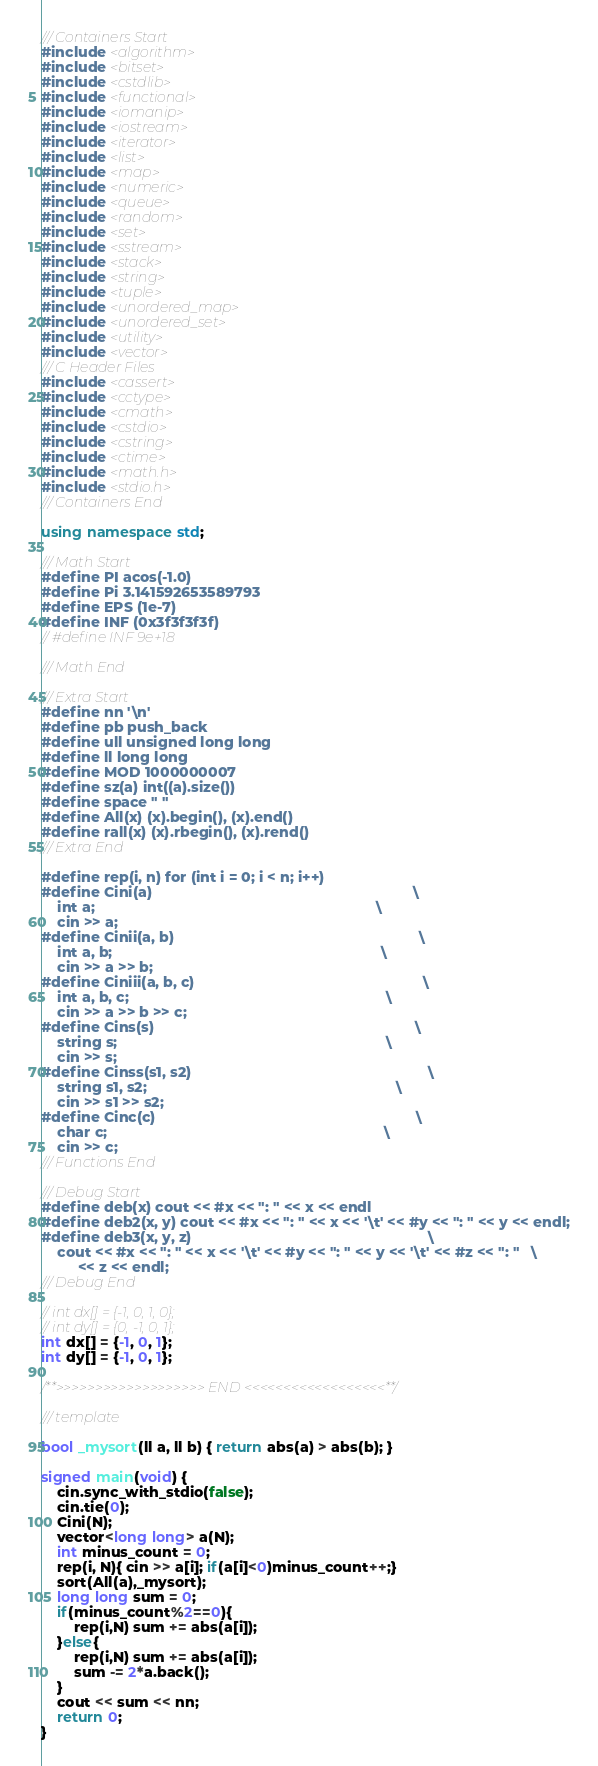Convert code to text. <code><loc_0><loc_0><loc_500><loc_500><_C++_>/// Containers Start
#include <algorithm>
#include <bitset>
#include <cstdlib>
#include <functional>
#include <iomanip>
#include <iostream>
#include <iterator>
#include <list>
#include <map>
#include <numeric>
#include <queue>
#include <random>
#include <set>
#include <sstream>
#include <stack>
#include <string>
#include <tuple>
#include <unordered_map>
#include <unordered_set>
#include <utility>
#include <vector>
/// C Header Files
#include <cassert>
#include <cctype>
#include <cmath>
#include <cstdio>
#include <cstring>
#include <ctime>
#include <math.h>
#include <stdio.h>
/// Containers End

using namespace std;

/// Math Start
#define PI acos(-1.0)
#define Pi 3.141592653589793
#define EPS (1e-7)
#define INF (0x3f3f3f3f)
// #define INF 9e+18

/// Math End

/// Extra Start
#define nn '\n'
#define pb push_back
#define ull unsigned long long
#define ll long long
#define MOD 1000000007
#define sz(a) int((a).size())
#define space " "
#define All(x) (x).begin(), (x).end()
#define rall(x) (x).rbegin(), (x).rend()
/// Extra End

#define rep(i, n) for (int i = 0; i < n; i++)
#define Cini(a)                                                                \
    int a;                                                                     \
    cin >> a;
#define Cinii(a, b)                                                            \
    int a, b;                                                                  \
    cin >> a >> b;
#define Ciniii(a, b, c)                                                        \
    int a, b, c;                                                               \
    cin >> a >> b >> c;
#define Cins(s)                                                                \
    string s;                                                                  \
    cin >> s;
#define Cinss(s1, s2)                                                          \
    string s1, s2;                                                             \
    cin >> s1 >> s2;
#define Cinc(c)                                                                \
    char c;                                                                    \
    cin >> c;
/// Functions End

/// Debug Start
#define deb(x) cout << #x << ": " << x << endl
#define deb2(x, y) cout << #x << ": " << x << '\t' << #y << ": " << y << endl;
#define deb3(x, y, z)                                                          \
    cout << #x << ": " << x << '\t' << #y << ": " << y << '\t' << #z << ": "   \
         << z << endl;
/// Debug End

// int dx[] = {-1, 0, 1, 0};
// int dy[] = {0, -1, 0, 1};
int dx[] = {-1, 0, 1};
int dy[] = {-1, 0, 1};

/**>>>>>>>>>>>>>>>>>>> END <<<<<<<<<<<<<<<<<<**/

/// template

bool _mysort(ll a, ll b) { return abs(a) > abs(b); }

signed main(void) {
    cin.sync_with_stdio(false);
    cin.tie(0);
    Cini(N);
    vector<long long> a(N);
    int minus_count = 0;
    rep(i, N){ cin >> a[i]; if(a[i]<0)minus_count++;}
    sort(All(a),_mysort);
    long long sum = 0;
    if(minus_count%2==0){
        rep(i,N) sum += abs(a[i]);
    }else{
        rep(i,N) sum += abs(a[i]);
        sum -= 2*a.back();
    }
    cout << sum << nn;
    return 0;
}
</code> 